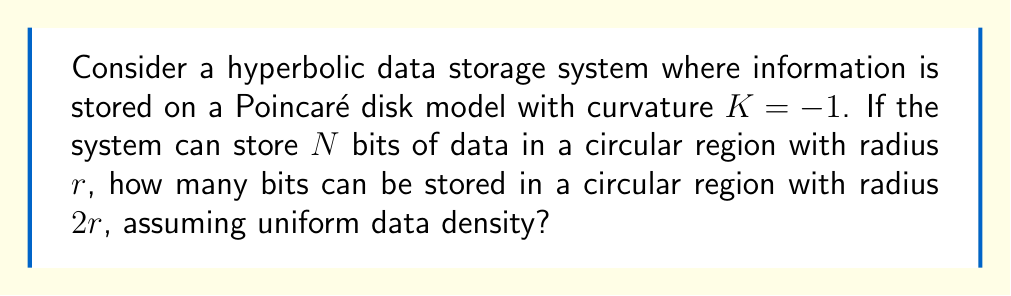Teach me how to tackle this problem. Let's approach this step-by-step:

1) In hyperbolic geometry, the area of a circle is given by:

   $$A(r) = 4\pi \sinh^2(\frac{r}{2})$$

   where $r$ is the radius and $K = -1$ is the curvature.

2) For the initial circle with radius $r$, the area is:

   $$A_1 = 4\pi \sinh^2(\frac{r}{2})$$

3) For the circle with radius $2r$, the area is:

   $$A_2 = 4\pi \sinh^2(r)$$

4) The ratio of these areas is:

   $$\frac{A_2}{A_1} = \frac{\sinh^2(r)}{\sinh^2(\frac{r}{2})}$$

5) Using the hyperbolic double angle formula:

   $$\sinh(2x) = 2\sinh(x)\cosh(x)$$

   We can derive:

   $$\sinh^2(r) = \sinh^2(\frac{r}{2})(4\cosh^2(\frac{r}{2}) - 1)$$

6) Substituting this into our ratio:

   $$\frac{A_2}{A_1} = 4\cosh^2(\frac{r}{2}) - 1$$

7) As $\cosh(x) > 1$ for all $x > 0$, this ratio is always greater than 3.

8) Given that the data density is uniform, the number of bits that can be stored is directly proportional to the area. Therefore, if $N$ bits can be stored in the smaller circle, then $N(4\cosh^2(\frac{r}{2}) - 1)$ bits can be stored in the larger circle.

In C# terms, this could be implemented as:

```csharp
double CalculateDataCapacity(double r, int N)
{
    return N * (4 * Math.Pow(Math.Cosh(r / 2), 2) - 1);
}
```

This demonstrates how the hyperbolic nature of the space allows for more efficient data storage as the radius increases, compared to Euclidean geometry where the ratio would simply be 4.
Answer: $N(4\cosh^2(\frac{r}{2}) - 1)$ bits 